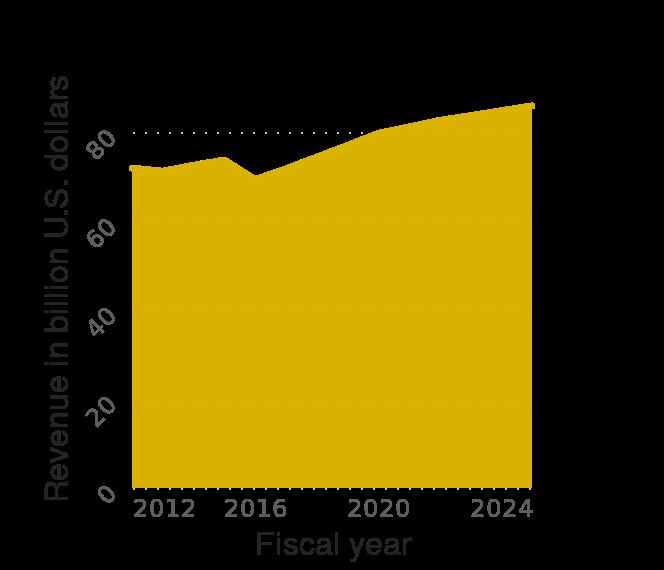<image>
What is the maximum revenue recorded for Target in the United States during the given period?  The maximum revenue recorded for Target in the United States during the given period is $80 billion. What is the total revenue of Target in the United States in 2025?  The total revenue of Target in the United States in 2025 is not provided in the description. Was there a decrease in revenue in 2016? Yes, there was a dip in revenue in 2016. 